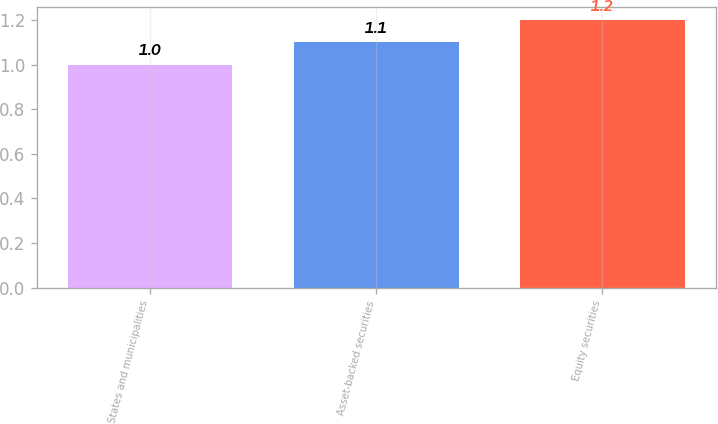Convert chart to OTSL. <chart><loc_0><loc_0><loc_500><loc_500><bar_chart><fcel>States and municipalities<fcel>Asset-backed securities<fcel>Equity securities<nl><fcel>1<fcel>1.1<fcel>1.2<nl></chart> 